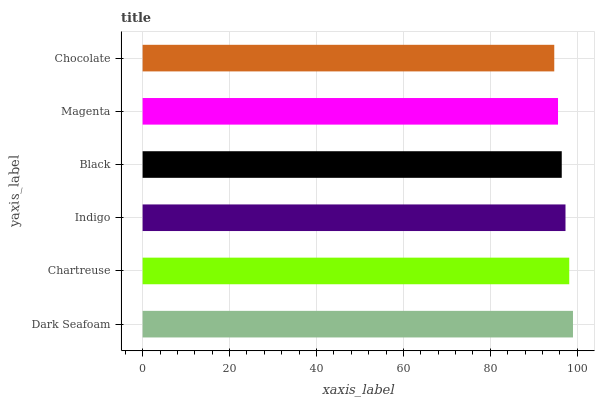Is Chocolate the minimum?
Answer yes or no. Yes. Is Dark Seafoam the maximum?
Answer yes or no. Yes. Is Chartreuse the minimum?
Answer yes or no. No. Is Chartreuse the maximum?
Answer yes or no. No. Is Dark Seafoam greater than Chartreuse?
Answer yes or no. Yes. Is Chartreuse less than Dark Seafoam?
Answer yes or no. Yes. Is Chartreuse greater than Dark Seafoam?
Answer yes or no. No. Is Dark Seafoam less than Chartreuse?
Answer yes or no. No. Is Indigo the high median?
Answer yes or no. Yes. Is Black the low median?
Answer yes or no. Yes. Is Chocolate the high median?
Answer yes or no. No. Is Chocolate the low median?
Answer yes or no. No. 